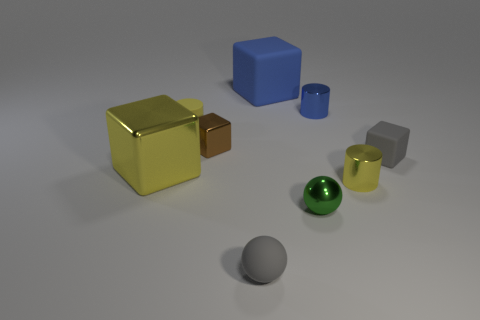Subtract all brown cubes. How many yellow cylinders are left? 2 Subtract all blue blocks. How many blocks are left? 3 Subtract all large yellow metal cubes. How many cubes are left? 3 Subtract all cyan cubes. Subtract all brown balls. How many cubes are left? 4 Add 1 blue matte cubes. How many objects exist? 10 Subtract all cylinders. How many objects are left? 6 Add 1 metallic cylinders. How many metallic cylinders exist? 3 Subtract 0 gray cylinders. How many objects are left? 9 Subtract all metal spheres. Subtract all cyan rubber balls. How many objects are left? 8 Add 8 large blue matte cubes. How many large blue matte cubes are left? 9 